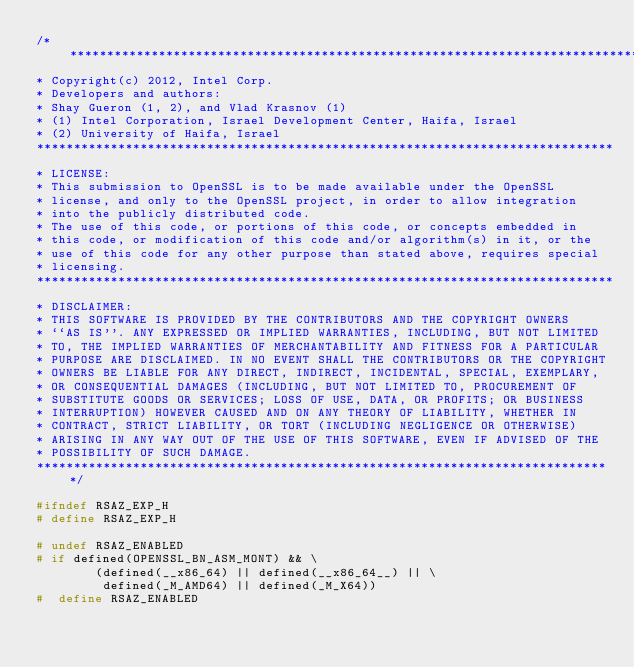Convert code to text. <code><loc_0><loc_0><loc_500><loc_500><_C_>/******************************************************************************
* Copyright(c) 2012, Intel Corp.
* Developers and authors:
* Shay Gueron (1, 2), and Vlad Krasnov (1)
* (1) Intel Corporation, Israel Development Center, Haifa, Israel
* (2) University of Haifa, Israel
******************************************************************************
* LICENSE:
* This submission to OpenSSL is to be made available under the OpenSSL
* license, and only to the OpenSSL project, in order to allow integration
* into the publicly distributed code.
* The use of this code, or portions of this code, or concepts embedded in
* this code, or modification of this code and/or algorithm(s) in it, or the
* use of this code for any other purpose than stated above, requires special
* licensing.
******************************************************************************
* DISCLAIMER:
* THIS SOFTWARE IS PROVIDED BY THE CONTRIBUTORS AND THE COPYRIGHT OWNERS
* ``AS IS''. ANY EXPRESSED OR IMPLIED WARRANTIES, INCLUDING, BUT NOT LIMITED
* TO, THE IMPLIED WARRANTIES OF MERCHANTABILITY AND FITNESS FOR A PARTICULAR
* PURPOSE ARE DISCLAIMED. IN NO EVENT SHALL THE CONTRIBUTORS OR THE COPYRIGHT
* OWNERS BE LIABLE FOR ANY DIRECT, INDIRECT, INCIDENTAL, SPECIAL, EXEMPLARY,
* OR CONSEQUENTIAL DAMAGES (INCLUDING, BUT NOT LIMITED TO, PROCUREMENT OF
* SUBSTITUTE GOODS OR SERVICES; LOSS OF USE, DATA, OR PROFITS; OR BUSINESS
* INTERRUPTION) HOWEVER CAUSED AND ON ANY THEORY OF LIABILITY, WHETHER IN
* CONTRACT, STRICT LIABILITY, OR TORT (INCLUDING NEGLIGENCE OR OTHERWISE)
* ARISING IN ANY WAY OUT OF THE USE OF THIS SOFTWARE, EVEN IF ADVISED OF THE
* POSSIBILITY OF SUCH DAMAGE.
******************************************************************************/

#ifndef RSAZ_EXP_H
# define RSAZ_EXP_H

# undef RSAZ_ENABLED
# if defined(OPENSSL_BN_ASM_MONT) && \
        (defined(__x86_64) || defined(__x86_64__) || \
         defined(_M_AMD64) || defined(_M_X64))
#  define RSAZ_ENABLED
</code> 